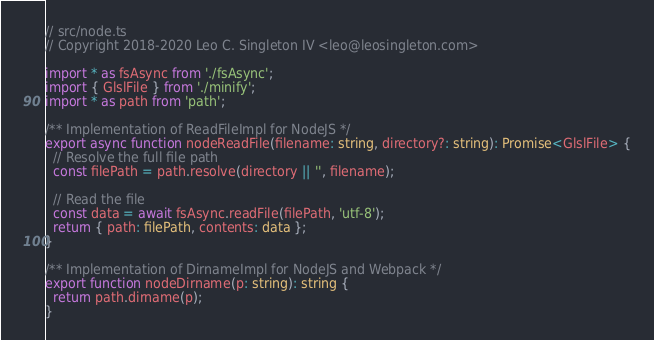<code> <loc_0><loc_0><loc_500><loc_500><_TypeScript_>// src/node.ts
// Copyright 2018-2020 Leo C. Singleton IV <leo@leosingleton.com>

import * as fsAsync from './fsAsync';
import { GlslFile } from './minify';
import * as path from 'path';

/** Implementation of ReadFileImpl for NodeJS */
export async function nodeReadFile(filename: string, directory?: string): Promise<GlslFile> {
  // Resolve the full file path
  const filePath = path.resolve(directory || '', filename);

  // Read the file
  const data = await fsAsync.readFile(filePath, 'utf-8');
  return { path: filePath, contents: data };
}

/** Implementation of DirnameImpl for NodeJS and Webpack */
export function nodeDirname(p: string): string {
  return path.dirname(p);
}
</code> 